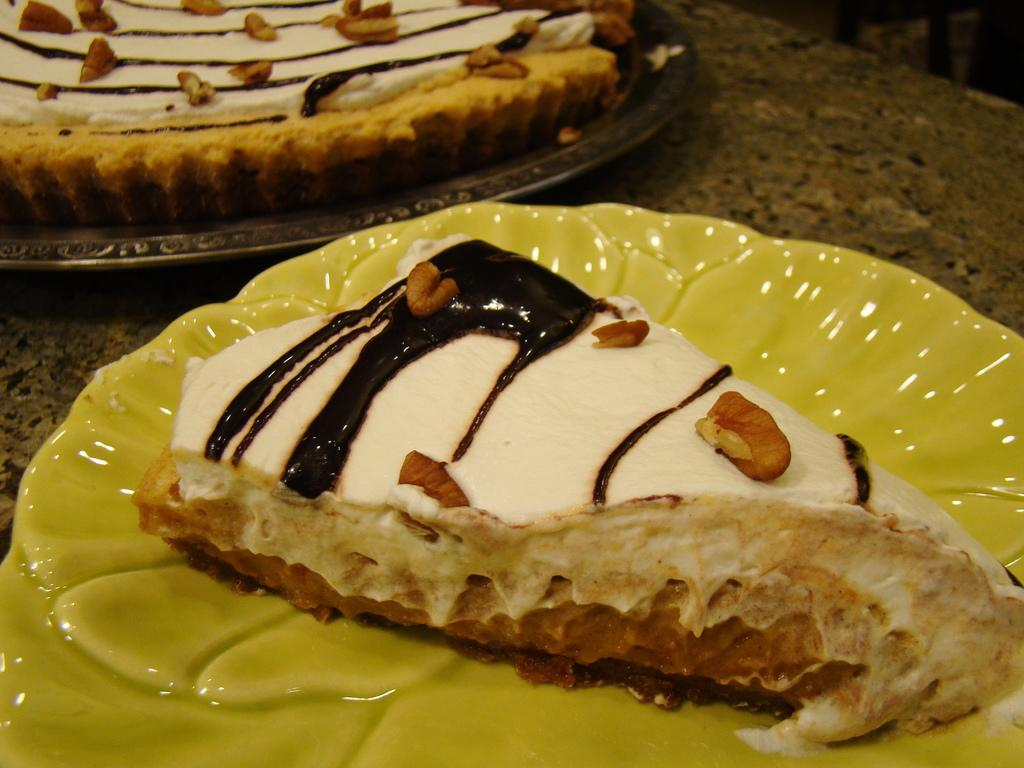What type of furniture is present in the image? There is a table in the image. What objects are placed on the table? There are plates and cakes on the table. Can you see any fairies waving at the cakes in the image? There are no fairies or waving actions present in the image. 